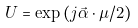<formula> <loc_0><loc_0><loc_500><loc_500>U = \exp { ( j \vec { \alpha } \cdot \mu / 2 ) }</formula> 